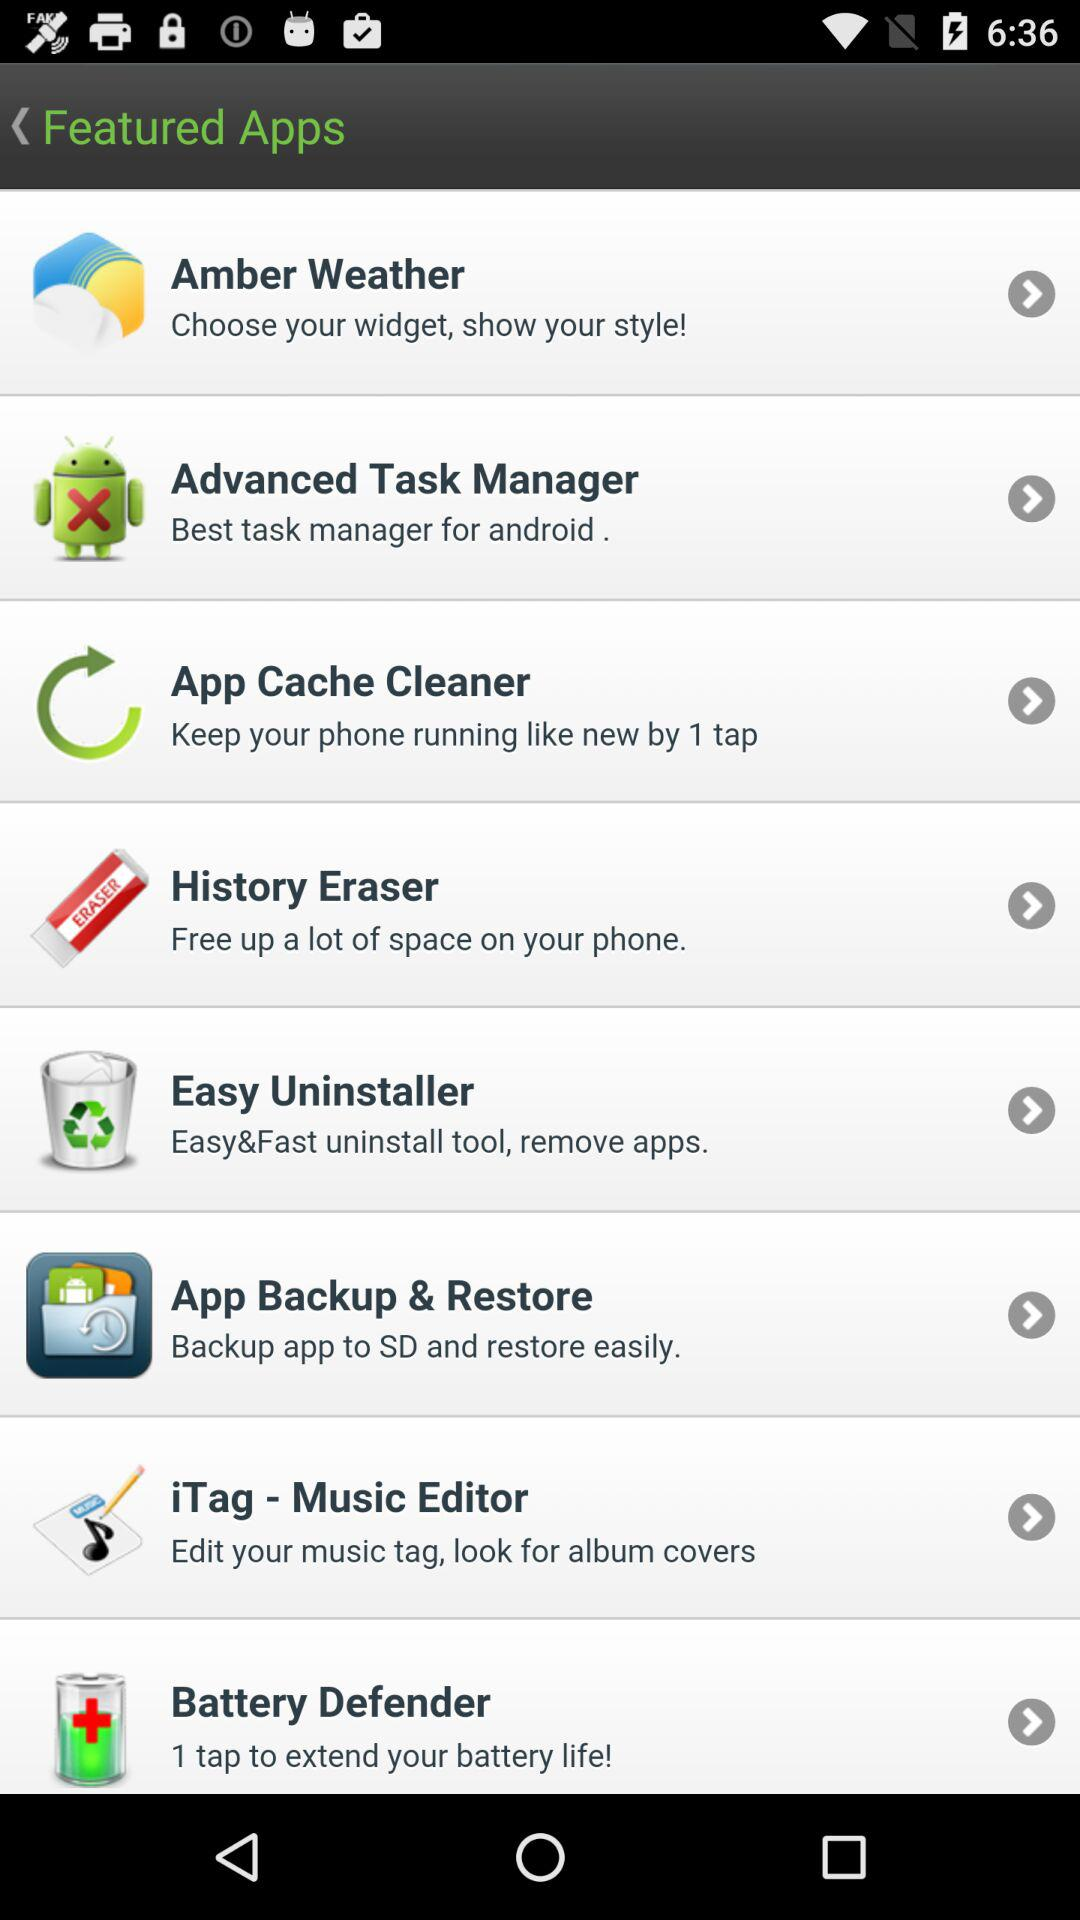What application can we use to choose your widget and show your style? The application is "Amber Weather". 